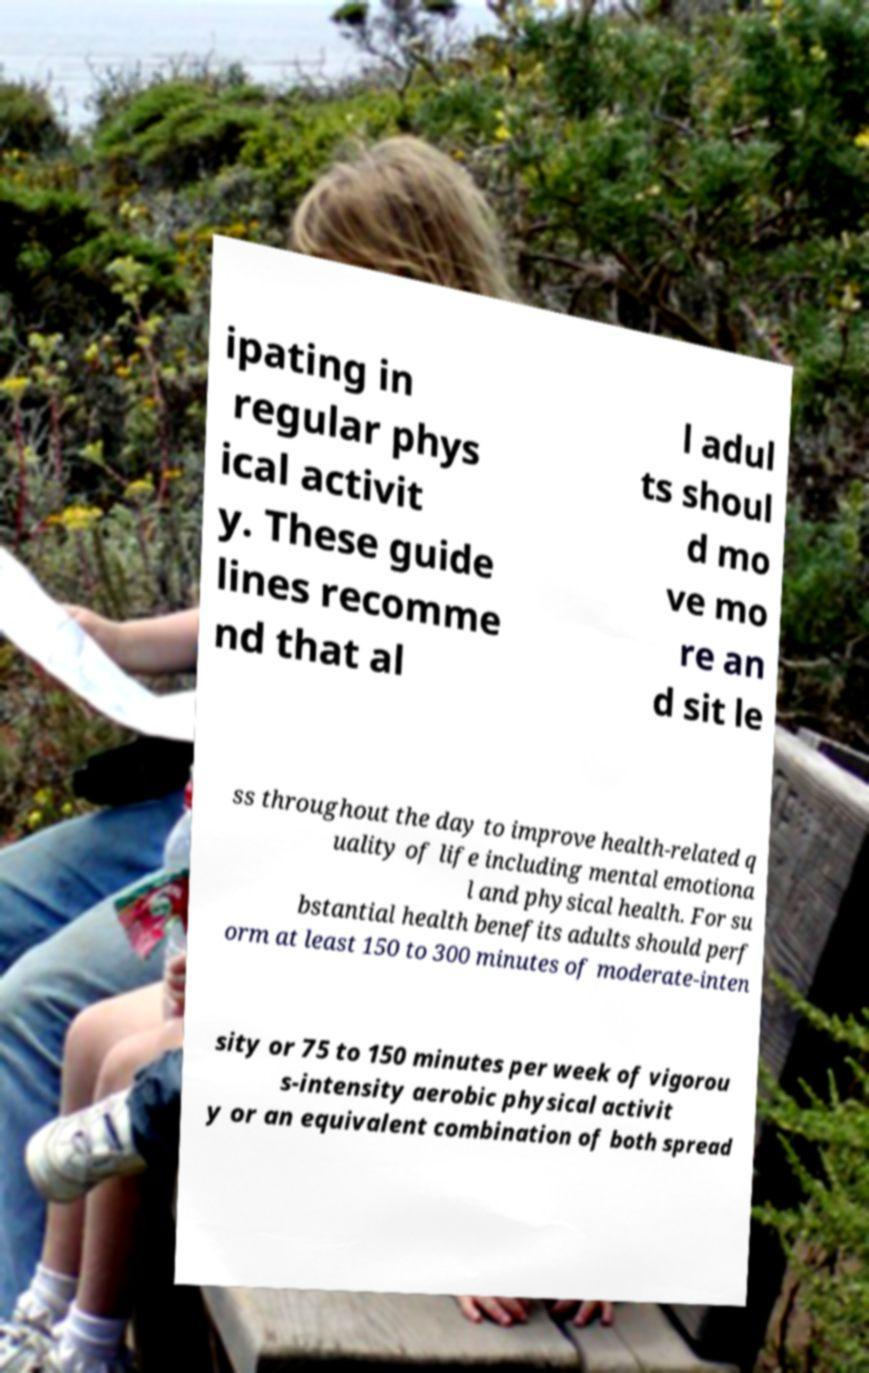For documentation purposes, I need the text within this image transcribed. Could you provide that? ipating in regular phys ical activit y. These guide lines recomme nd that al l adul ts shoul d mo ve mo re an d sit le ss throughout the day to improve health-related q uality of life including mental emotiona l and physical health. For su bstantial health benefits adults should perf orm at least 150 to 300 minutes of moderate-inten sity or 75 to 150 minutes per week of vigorou s-intensity aerobic physical activit y or an equivalent combination of both spread 